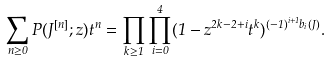<formula> <loc_0><loc_0><loc_500><loc_500>\sum _ { n \geq 0 } P ( J ^ { [ n ] } ; z ) t ^ { n } = \prod _ { k \geq 1 } \prod _ { i = 0 } ^ { 4 } ( 1 - z ^ { 2 k - 2 + i } t ^ { k } ) ^ { ( - 1 ) ^ { i + 1 } b _ { i } ( J ) } .</formula> 